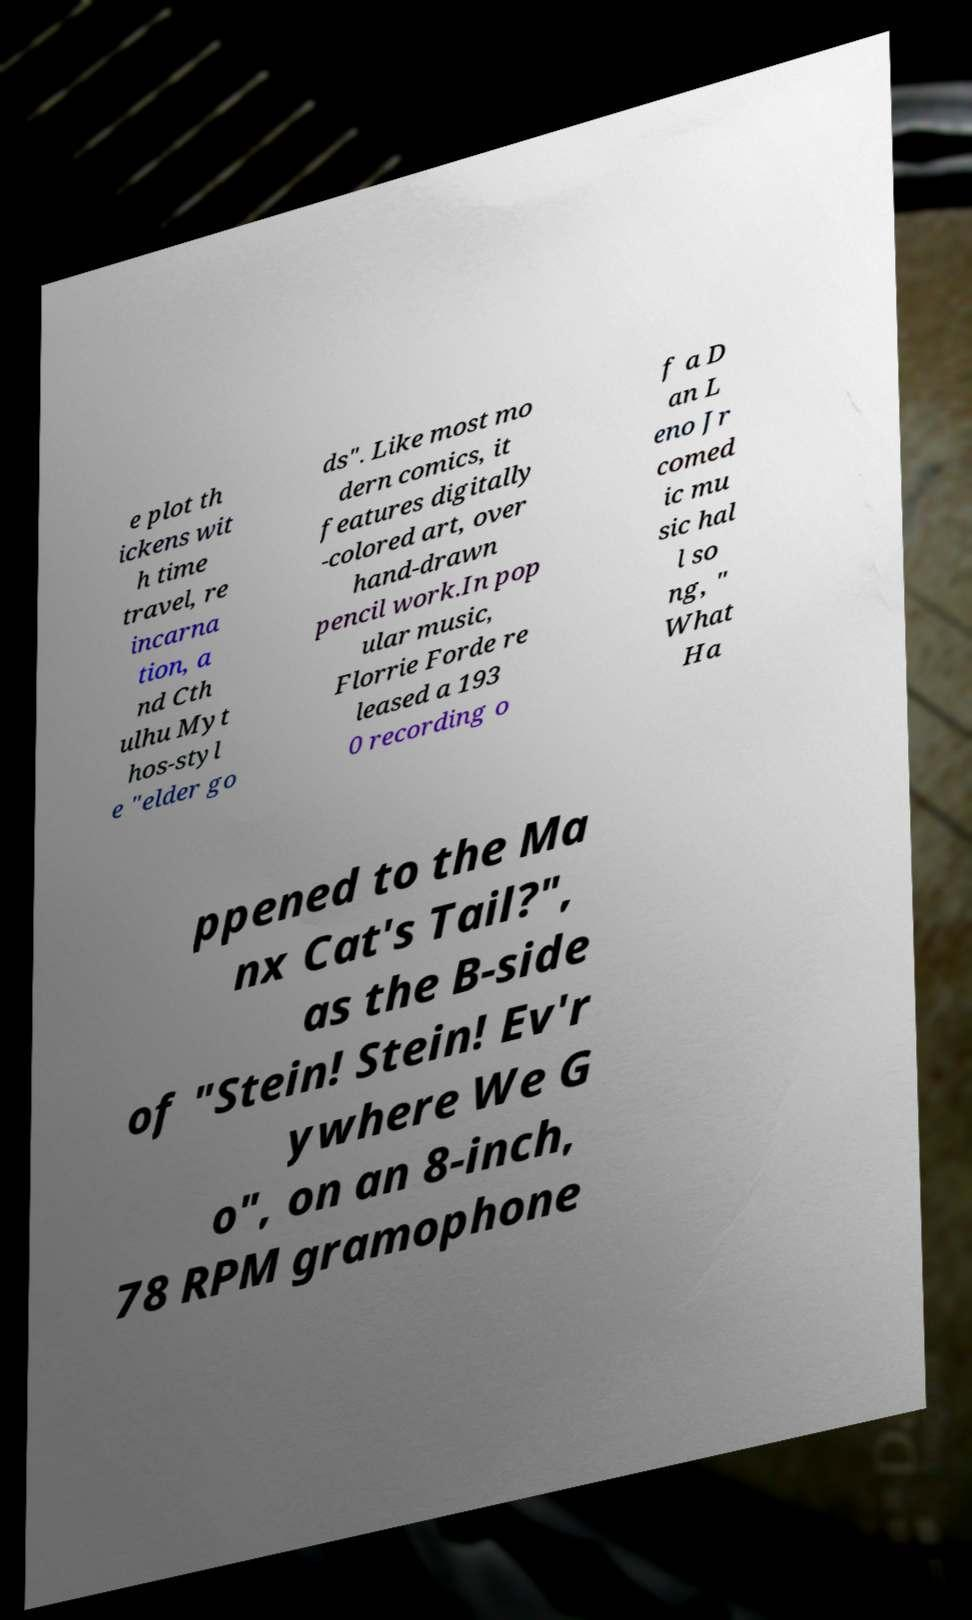For documentation purposes, I need the text within this image transcribed. Could you provide that? e plot th ickens wit h time travel, re incarna tion, a nd Cth ulhu Myt hos-styl e "elder go ds". Like most mo dern comics, it features digitally -colored art, over hand-drawn pencil work.In pop ular music, Florrie Forde re leased a 193 0 recording o f a D an L eno Jr comed ic mu sic hal l so ng, " What Ha ppened to the Ma nx Cat's Tail?", as the B-side of "Stein! Stein! Ev'r ywhere We G o", on an 8-inch, 78 RPM gramophone 